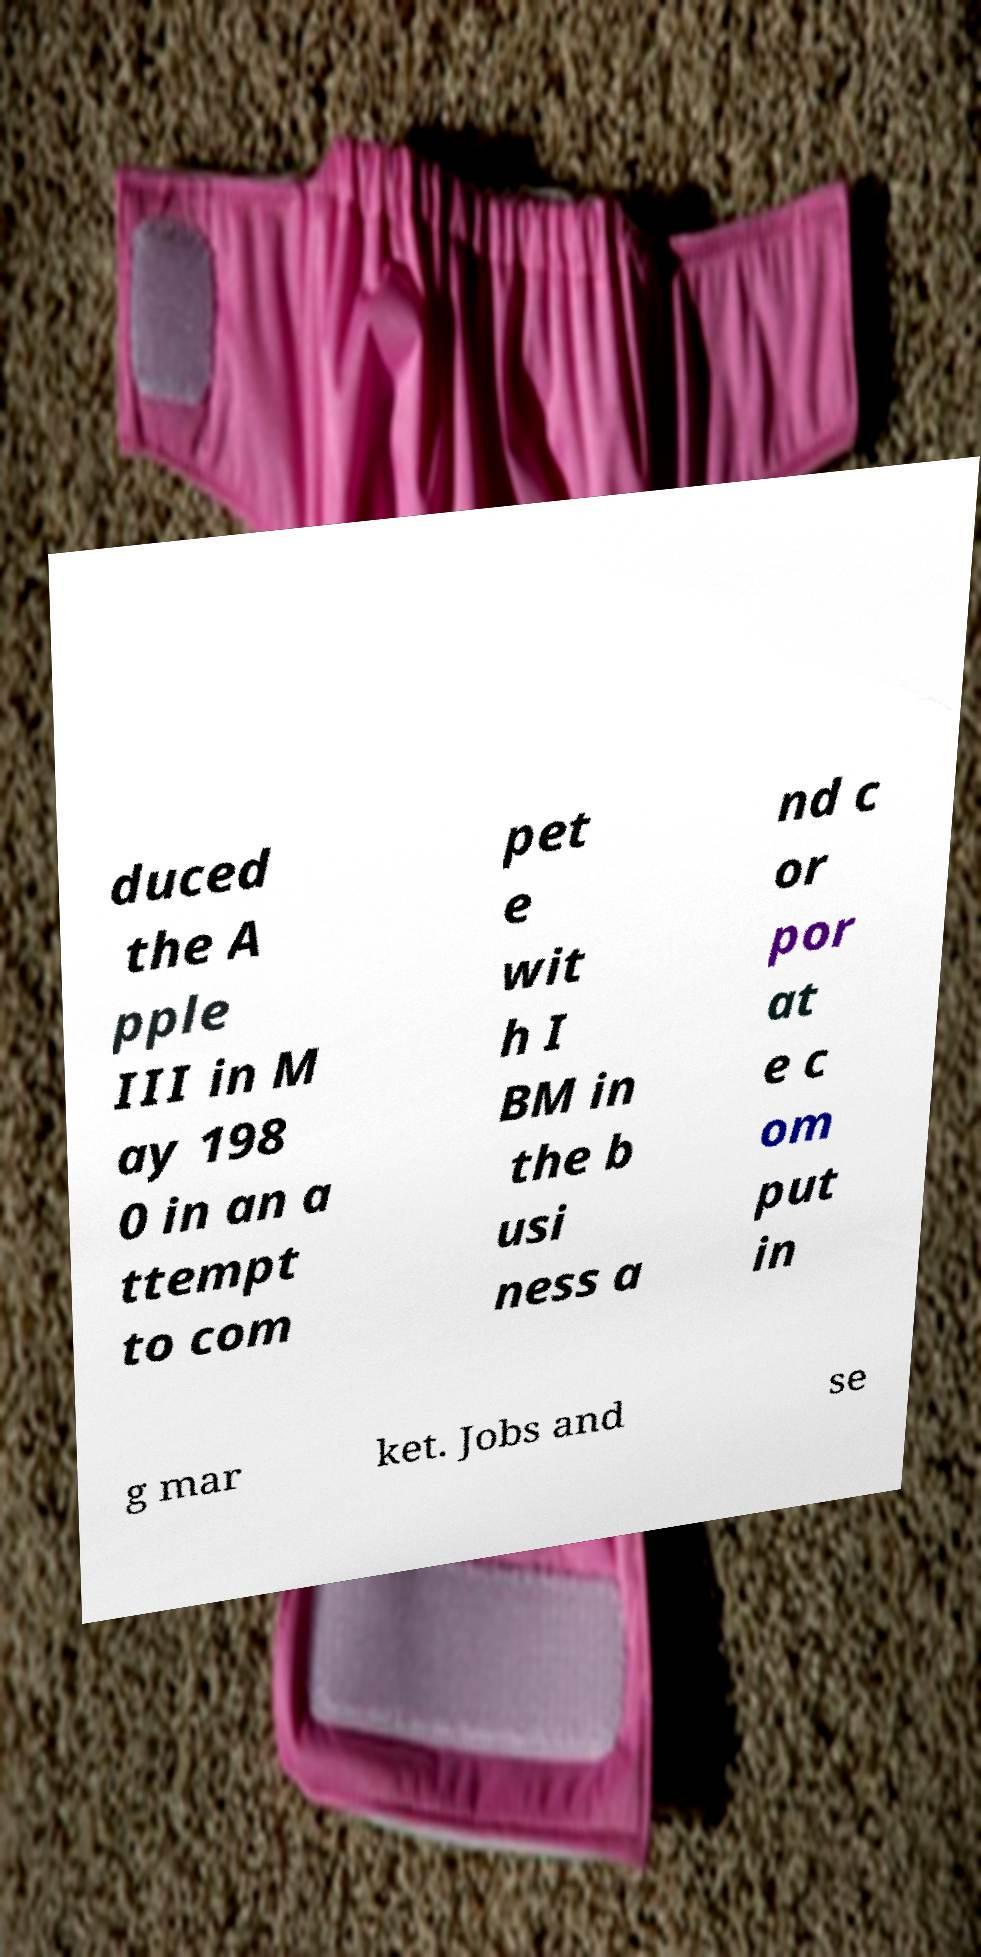Can you accurately transcribe the text from the provided image for me? duced the A pple III in M ay 198 0 in an a ttempt to com pet e wit h I BM in the b usi ness a nd c or por at e c om put in g mar ket. Jobs and se 